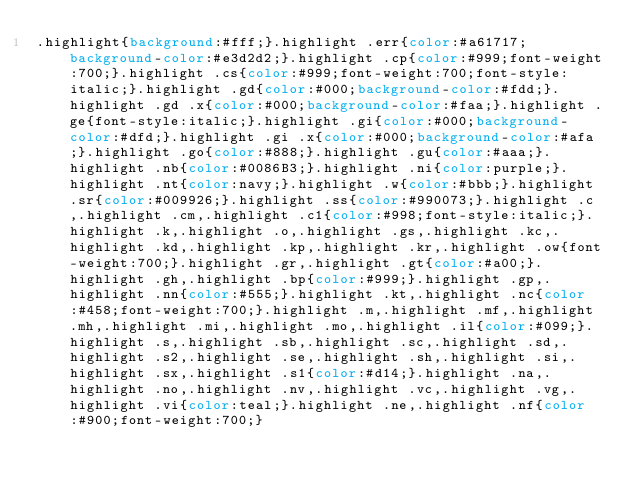<code> <loc_0><loc_0><loc_500><loc_500><_CSS_>.highlight{background:#fff;}.highlight .err{color:#a61717;background-color:#e3d2d2;}.highlight .cp{color:#999;font-weight:700;}.highlight .cs{color:#999;font-weight:700;font-style:italic;}.highlight .gd{color:#000;background-color:#fdd;}.highlight .gd .x{color:#000;background-color:#faa;}.highlight .ge{font-style:italic;}.highlight .gi{color:#000;background-color:#dfd;}.highlight .gi .x{color:#000;background-color:#afa;}.highlight .go{color:#888;}.highlight .gu{color:#aaa;}.highlight .nb{color:#0086B3;}.highlight .ni{color:purple;}.highlight .nt{color:navy;}.highlight .w{color:#bbb;}.highlight .sr{color:#009926;}.highlight .ss{color:#990073;}.highlight .c,.highlight .cm,.highlight .c1{color:#998;font-style:italic;}.highlight .k,.highlight .o,.highlight .gs,.highlight .kc,.highlight .kd,.highlight .kp,.highlight .kr,.highlight .ow{font-weight:700;}.highlight .gr,.highlight .gt{color:#a00;}.highlight .gh,.highlight .bp{color:#999;}.highlight .gp,.highlight .nn{color:#555;}.highlight .kt,.highlight .nc{color:#458;font-weight:700;}.highlight .m,.highlight .mf,.highlight .mh,.highlight .mi,.highlight .mo,.highlight .il{color:#099;}.highlight .s,.highlight .sb,.highlight .sc,.highlight .sd,.highlight .s2,.highlight .se,.highlight .sh,.highlight .si,.highlight .sx,.highlight .s1{color:#d14;}.highlight .na,.highlight .no,.highlight .nv,.highlight .vc,.highlight .vg,.highlight .vi{color:teal;}.highlight .ne,.highlight .nf{color:#900;font-weight:700;}
</code> 